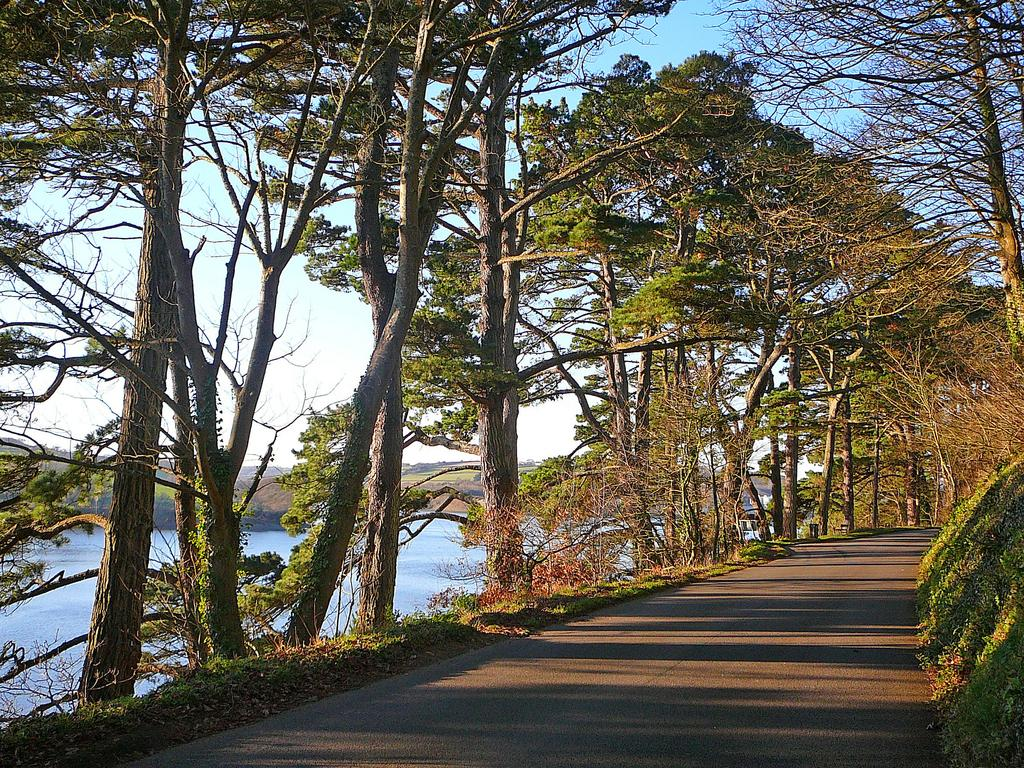What is the main feature of the image? There is a road in the image. What can be seen alongside the road? There are trees on the side of the road. What natural feature is present on the left side of the road? There is a river on the left side of the road. What is visible in the background of the image? The sky is visible in the background of the image. What type of soup can be seen simmering in the river in the image? There is no soup present in the image; it features a road, trees, and a river. What drug is being administered to the trees on the side of the road in the image? There is no drug being administered to the trees in the image; they are simply trees alongside the road. 